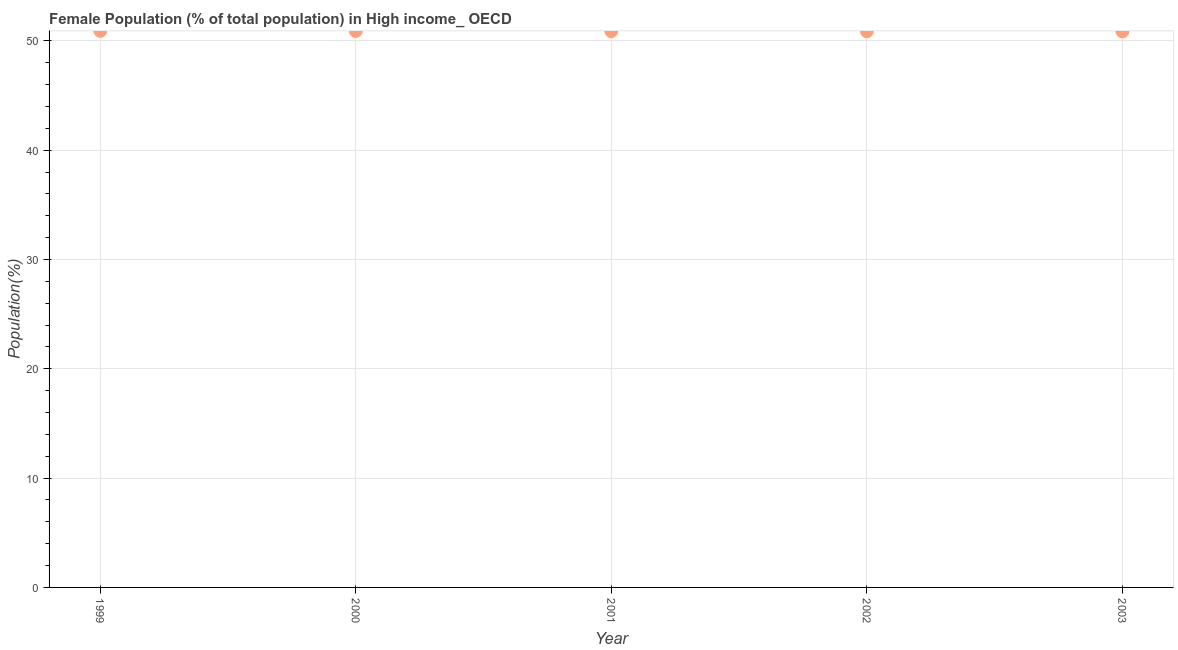What is the female population in 2001?
Offer a very short reply. 50.9. Across all years, what is the maximum female population?
Make the answer very short. 50.92. Across all years, what is the minimum female population?
Make the answer very short. 50.88. In which year was the female population maximum?
Provide a succinct answer. 1999. In which year was the female population minimum?
Your answer should be very brief. 2003. What is the sum of the female population?
Provide a succinct answer. 254.5. What is the difference between the female population in 2000 and 2002?
Keep it short and to the point. 0.02. What is the average female population per year?
Provide a succinct answer. 50.9. What is the median female population?
Provide a succinct answer. 50.9. In how many years, is the female population greater than 22 %?
Offer a very short reply. 5. Do a majority of the years between 2000 and 2002 (inclusive) have female population greater than 12 %?
Your answer should be very brief. Yes. What is the ratio of the female population in 1999 to that in 2001?
Provide a short and direct response. 1. What is the difference between the highest and the second highest female population?
Offer a very short reply. 0.01. Is the sum of the female population in 1999 and 2003 greater than the maximum female population across all years?
Provide a short and direct response. Yes. What is the difference between the highest and the lowest female population?
Offer a very short reply. 0.04. In how many years, is the female population greater than the average female population taken over all years?
Ensure brevity in your answer.  2. Are the values on the major ticks of Y-axis written in scientific E-notation?
Give a very brief answer. No. Does the graph contain any zero values?
Ensure brevity in your answer.  No. What is the title of the graph?
Your answer should be compact. Female Population (% of total population) in High income_ OECD. What is the label or title of the X-axis?
Provide a short and direct response. Year. What is the label or title of the Y-axis?
Your answer should be very brief. Population(%). What is the Population(%) in 1999?
Provide a short and direct response. 50.92. What is the Population(%) in 2000?
Your answer should be compact. 50.91. What is the Population(%) in 2001?
Make the answer very short. 50.9. What is the Population(%) in 2002?
Give a very brief answer. 50.89. What is the Population(%) in 2003?
Your response must be concise. 50.88. What is the difference between the Population(%) in 1999 and 2000?
Offer a very short reply. 0.01. What is the difference between the Population(%) in 1999 and 2001?
Your response must be concise. 0.02. What is the difference between the Population(%) in 1999 and 2002?
Offer a terse response. 0.03. What is the difference between the Population(%) in 1999 and 2003?
Your answer should be compact. 0.04. What is the difference between the Population(%) in 2000 and 2001?
Give a very brief answer. 0.01. What is the difference between the Population(%) in 2000 and 2002?
Provide a short and direct response. 0.02. What is the difference between the Population(%) in 2000 and 2003?
Offer a very short reply. 0.03. What is the difference between the Population(%) in 2001 and 2002?
Offer a very short reply. 0.01. What is the difference between the Population(%) in 2001 and 2003?
Offer a terse response. 0.02. What is the difference between the Population(%) in 2002 and 2003?
Offer a very short reply. 0.01. What is the ratio of the Population(%) in 1999 to that in 2000?
Your answer should be very brief. 1. What is the ratio of the Population(%) in 2000 to that in 2001?
Your answer should be compact. 1. What is the ratio of the Population(%) in 2002 to that in 2003?
Keep it short and to the point. 1. 